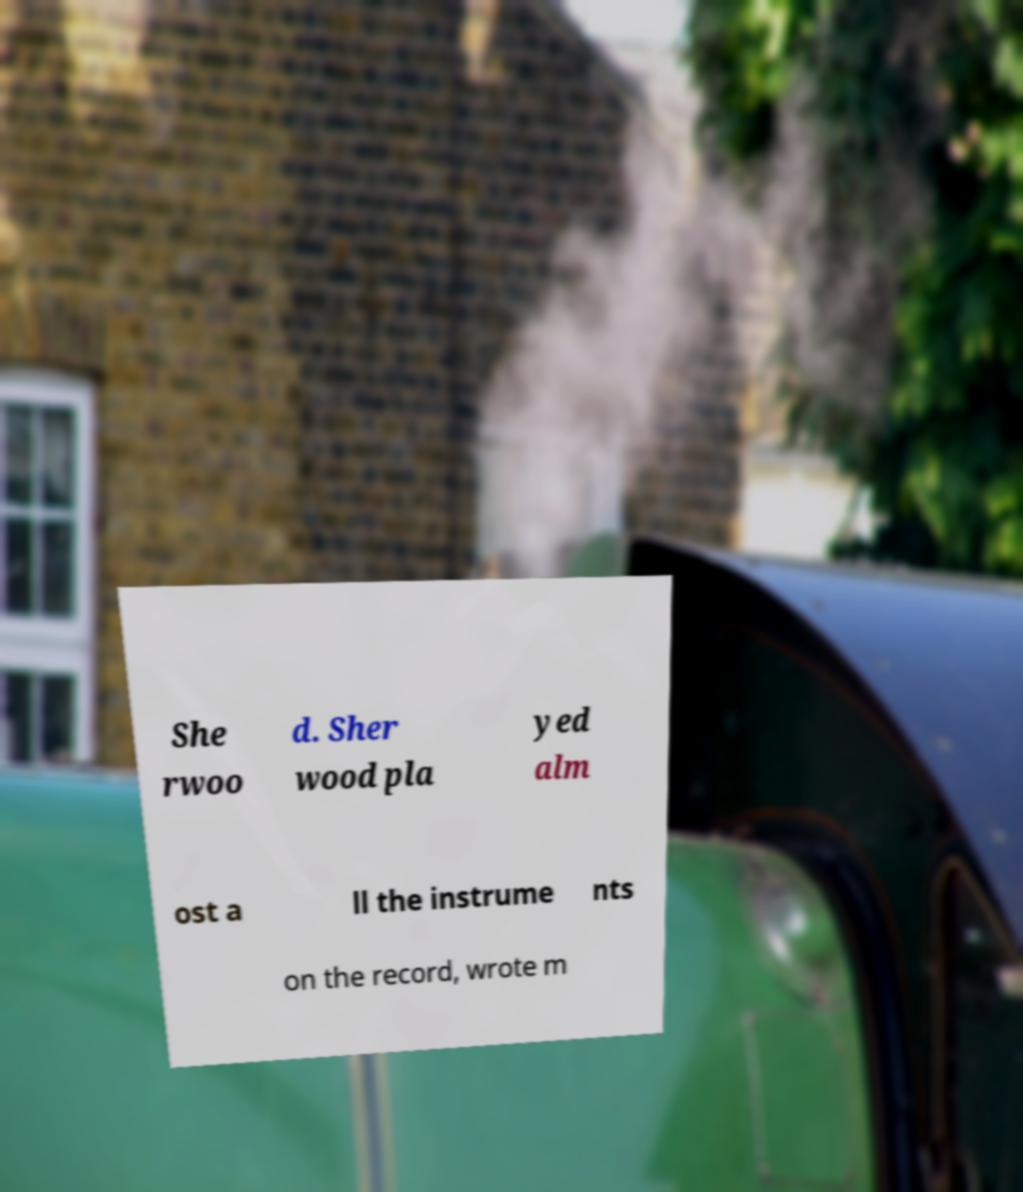Could you assist in decoding the text presented in this image and type it out clearly? She rwoo d. Sher wood pla yed alm ost a ll the instrume nts on the record, wrote m 